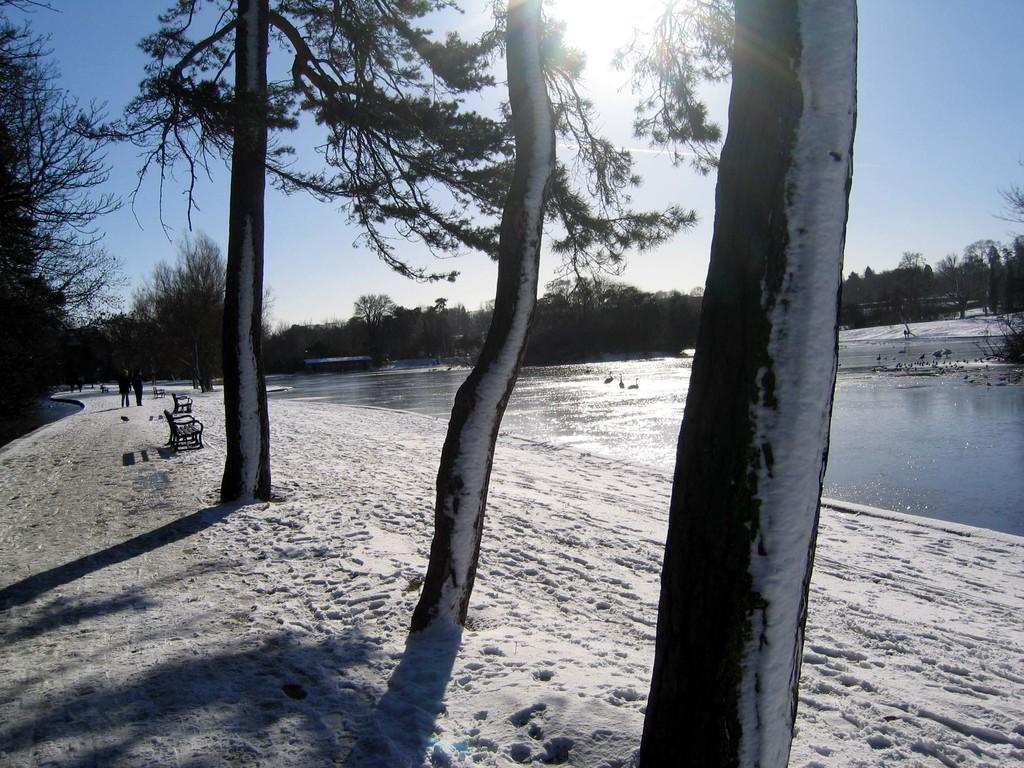What type of vegetation is present in the image? There are trees in the image. What type of seating is available in the image? There are benches in the image. What are the people in the image doing? There are persons walking in the image. What natural element is visible in the image? There is water visible in the image. What is the condition of the sky in the image? The sky is clear and visible at the top of the image. Can you tell me how many fish are swimming in the water in the image? There are no fish visible in the image; it only shows water. What type of store can be seen in the image? There is no store present in the image. 